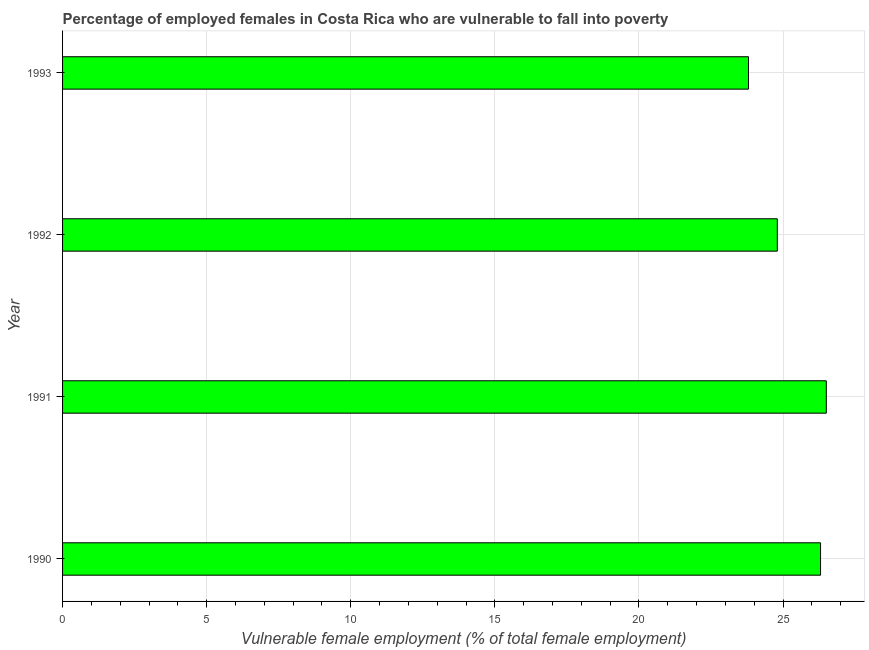Does the graph contain any zero values?
Make the answer very short. No. What is the title of the graph?
Ensure brevity in your answer.  Percentage of employed females in Costa Rica who are vulnerable to fall into poverty. What is the label or title of the X-axis?
Your answer should be very brief. Vulnerable female employment (% of total female employment). What is the percentage of employed females who are vulnerable to fall into poverty in 1992?
Provide a short and direct response. 24.8. Across all years, what is the minimum percentage of employed females who are vulnerable to fall into poverty?
Keep it short and to the point. 23.8. In which year was the percentage of employed females who are vulnerable to fall into poverty maximum?
Your answer should be very brief. 1991. In which year was the percentage of employed females who are vulnerable to fall into poverty minimum?
Ensure brevity in your answer.  1993. What is the sum of the percentage of employed females who are vulnerable to fall into poverty?
Your answer should be compact. 101.4. What is the average percentage of employed females who are vulnerable to fall into poverty per year?
Offer a very short reply. 25.35. What is the median percentage of employed females who are vulnerable to fall into poverty?
Provide a succinct answer. 25.55. What is the ratio of the percentage of employed females who are vulnerable to fall into poverty in 1990 to that in 1993?
Provide a succinct answer. 1.1. What is the difference between the highest and the second highest percentage of employed females who are vulnerable to fall into poverty?
Provide a short and direct response. 0.2. Is the sum of the percentage of employed females who are vulnerable to fall into poverty in 1990 and 1991 greater than the maximum percentage of employed females who are vulnerable to fall into poverty across all years?
Make the answer very short. Yes. What is the difference between the highest and the lowest percentage of employed females who are vulnerable to fall into poverty?
Your answer should be compact. 2.7. How many bars are there?
Your response must be concise. 4. How many years are there in the graph?
Offer a very short reply. 4. What is the difference between two consecutive major ticks on the X-axis?
Give a very brief answer. 5. What is the Vulnerable female employment (% of total female employment) of 1990?
Ensure brevity in your answer.  26.3. What is the Vulnerable female employment (% of total female employment) of 1992?
Give a very brief answer. 24.8. What is the Vulnerable female employment (% of total female employment) of 1993?
Ensure brevity in your answer.  23.8. What is the difference between the Vulnerable female employment (% of total female employment) in 1990 and 1991?
Give a very brief answer. -0.2. What is the difference between the Vulnerable female employment (% of total female employment) in 1990 and 1992?
Your answer should be very brief. 1.5. What is the difference between the Vulnerable female employment (% of total female employment) in 1990 and 1993?
Provide a short and direct response. 2.5. What is the ratio of the Vulnerable female employment (% of total female employment) in 1990 to that in 1992?
Make the answer very short. 1.06. What is the ratio of the Vulnerable female employment (% of total female employment) in 1990 to that in 1993?
Give a very brief answer. 1.1. What is the ratio of the Vulnerable female employment (% of total female employment) in 1991 to that in 1992?
Your answer should be very brief. 1.07. What is the ratio of the Vulnerable female employment (% of total female employment) in 1991 to that in 1993?
Offer a terse response. 1.11. What is the ratio of the Vulnerable female employment (% of total female employment) in 1992 to that in 1993?
Your answer should be very brief. 1.04. 